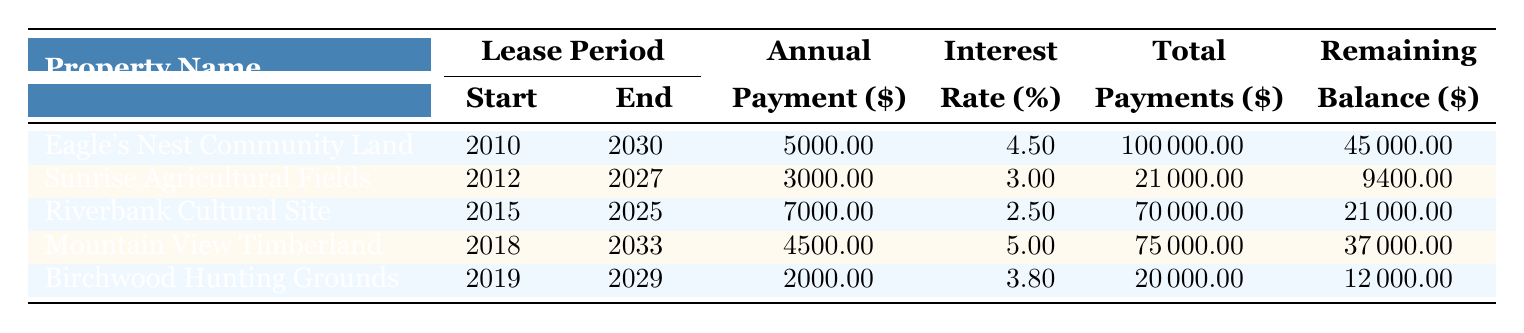What is the annual payment for the Riverbank Cultural Site? The table shows that the annual payment for the Riverbank Cultural Site is in the column labeled "Annual Payment ($)." Referring to that specific row, it indicates that the payment is 7000.00.
Answer: 7000.00 Which property has the highest remaining balance? To determine which property has the highest remaining balance, I compare the values in the "Remaining Balance ($)" column for each property. The Eagle's Nest Community Land has a remaining balance of 45000.00, which is greater than the other balances.
Answer: Eagle's Nest Community Land Is the interest rate for Mountain View Timberland higher than for Sunrise Agricultural Fields? The interest rate for Mountain View Timberland is 5.0% while the rate for Sunrise Agricultural Fields is 3.0%. Since 5.0% is greater than 3.0%, the statement is true.
Answer: Yes What is the total amount of land lease payments for properties with a remaining balance less than 20000? I examine the "Remaining Balance ($)" column and note the properties with balances less than 20000: Sunrise Agricultural Fields (9400.00) and Birchwood Hunting Grounds (12000.00). Adding their total payments: 21000.00 + 20000.00 equals 41000.00.
Answer: 41000.00 What is the average annual payment of all properties listed in the table? To find the average, I add the annual payments: 5000.00 + 3000.00 + 7000.00 + 4500.00 + 2000.00 equals 21500.00. There are 5 properties, so I divide the total by 5, which gives 21500.00 divided by 5 equals 4300.00.
Answer: 4300.00 Which property was leased starting in 2015? I can look in the "Lease Start" column and find that the Riverbank Cultural Site began its lease in 2015, identified in its row.
Answer: Riverbank Cultural Site How many properties have an interest rate of 4.5% or higher? From the "Interest Rate (%)" column, I check which properties have rates of 4.5% and above: Eagle's Nest Community Land (4.5%), Mountain View Timberland (5.0%). That gives a total of 2 properties.
Answer: 2 Is the total payment for Birchwood Hunting Grounds equal to its remaining balance? By looking at the table, the total payment for Birchwood Hunting Grounds is 20000.00 and its remaining balance is 12000.00. Since 20000.00 does not equal 12000.00, the statement is false.
Answer: No 